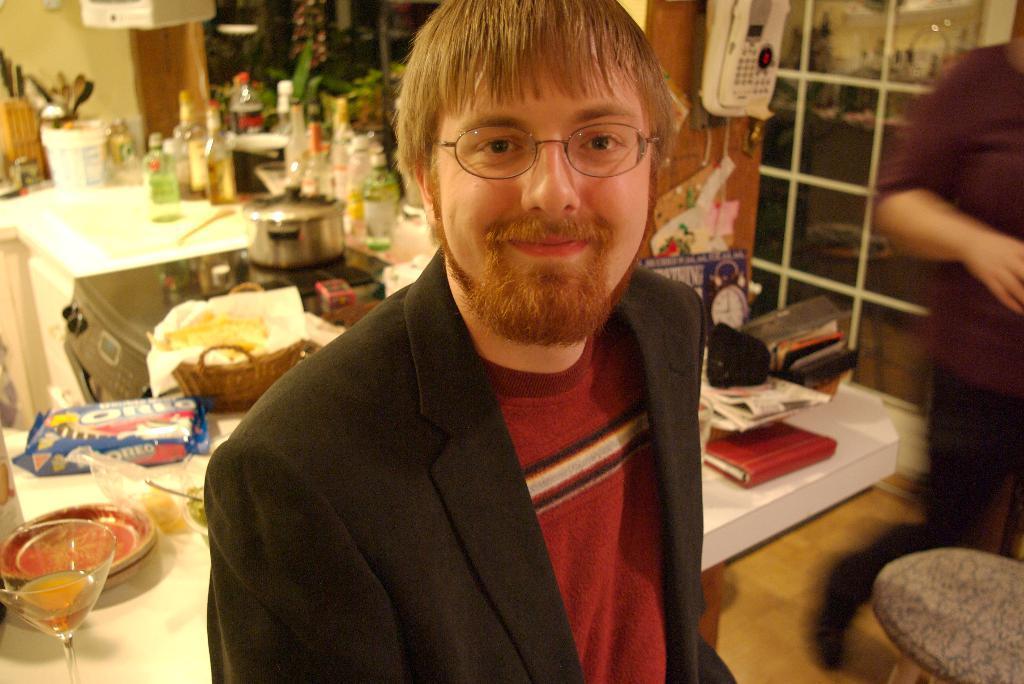Could you give a brief overview of what you see in this image? The man in black suit is highlighted in this picture. On this table there is a food pack, bowl, glass, bottles, spoons and container. On this stove there is a container. Telephone is on wall. This person is standing. On this table there is a red book. 